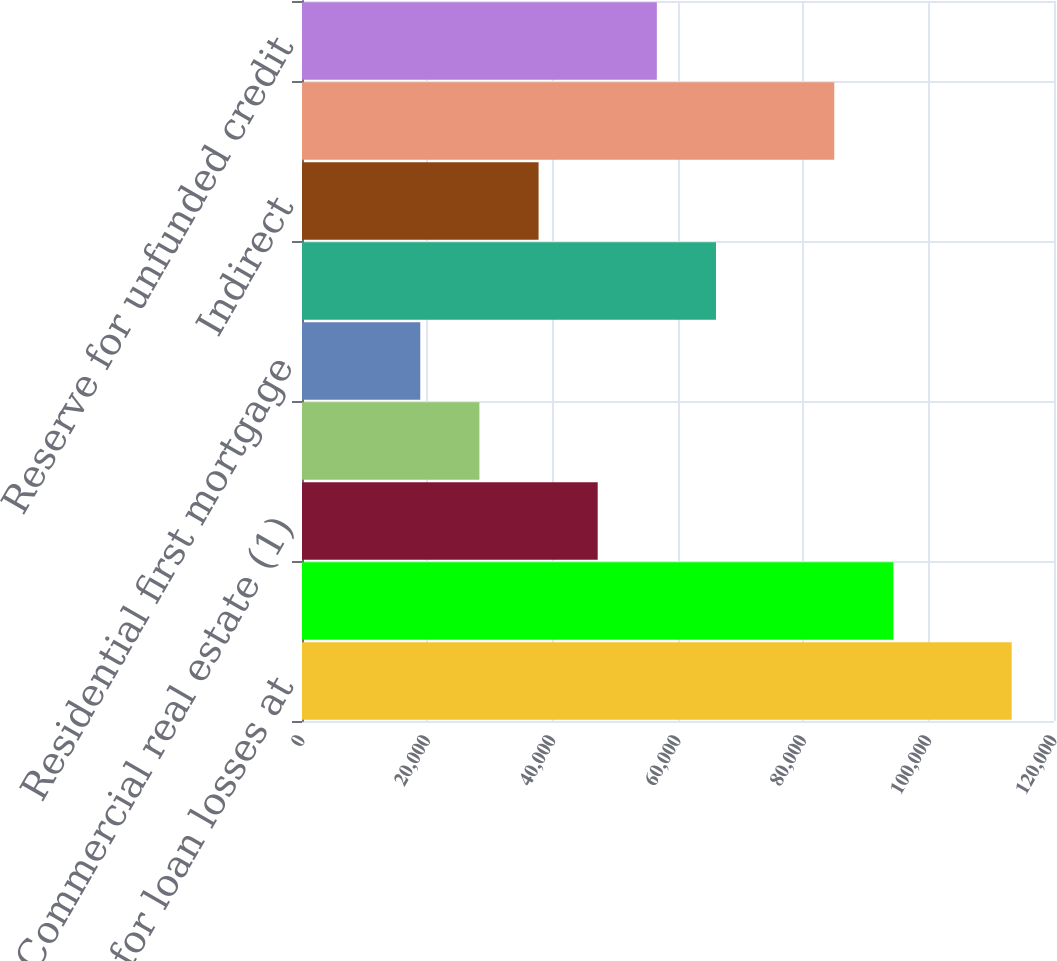Convert chart. <chart><loc_0><loc_0><loc_500><loc_500><bar_chart><fcel>Allowance for loan losses at<fcel>Commercial and industrial<fcel>Commercial real estate (1)<fcel>Construction<fcel>Residential first mortgage<fcel>Home equity<fcel>Indirect<fcel>Other consumer<fcel>Reserve for unfunded credit<nl><fcel>113246<fcel>94372<fcel>47186.1<fcel>28311.8<fcel>18874.6<fcel>66060.5<fcel>37749<fcel>84934.8<fcel>56623.3<nl></chart> 